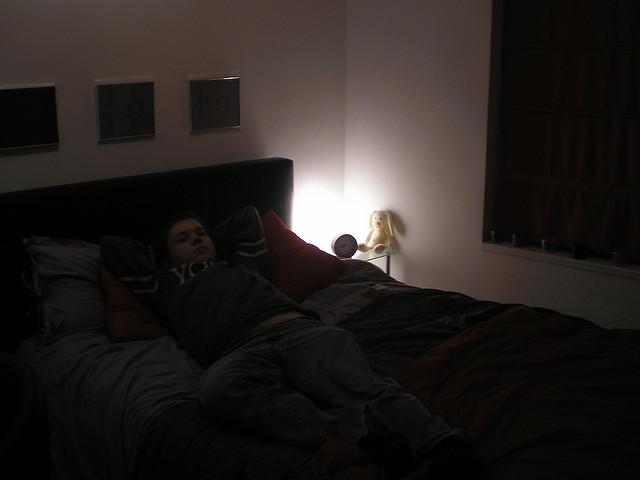The boy is most likely doing what?

Choices:
A) cooking
B) dreaming
C) exercising
D) running dreaming 